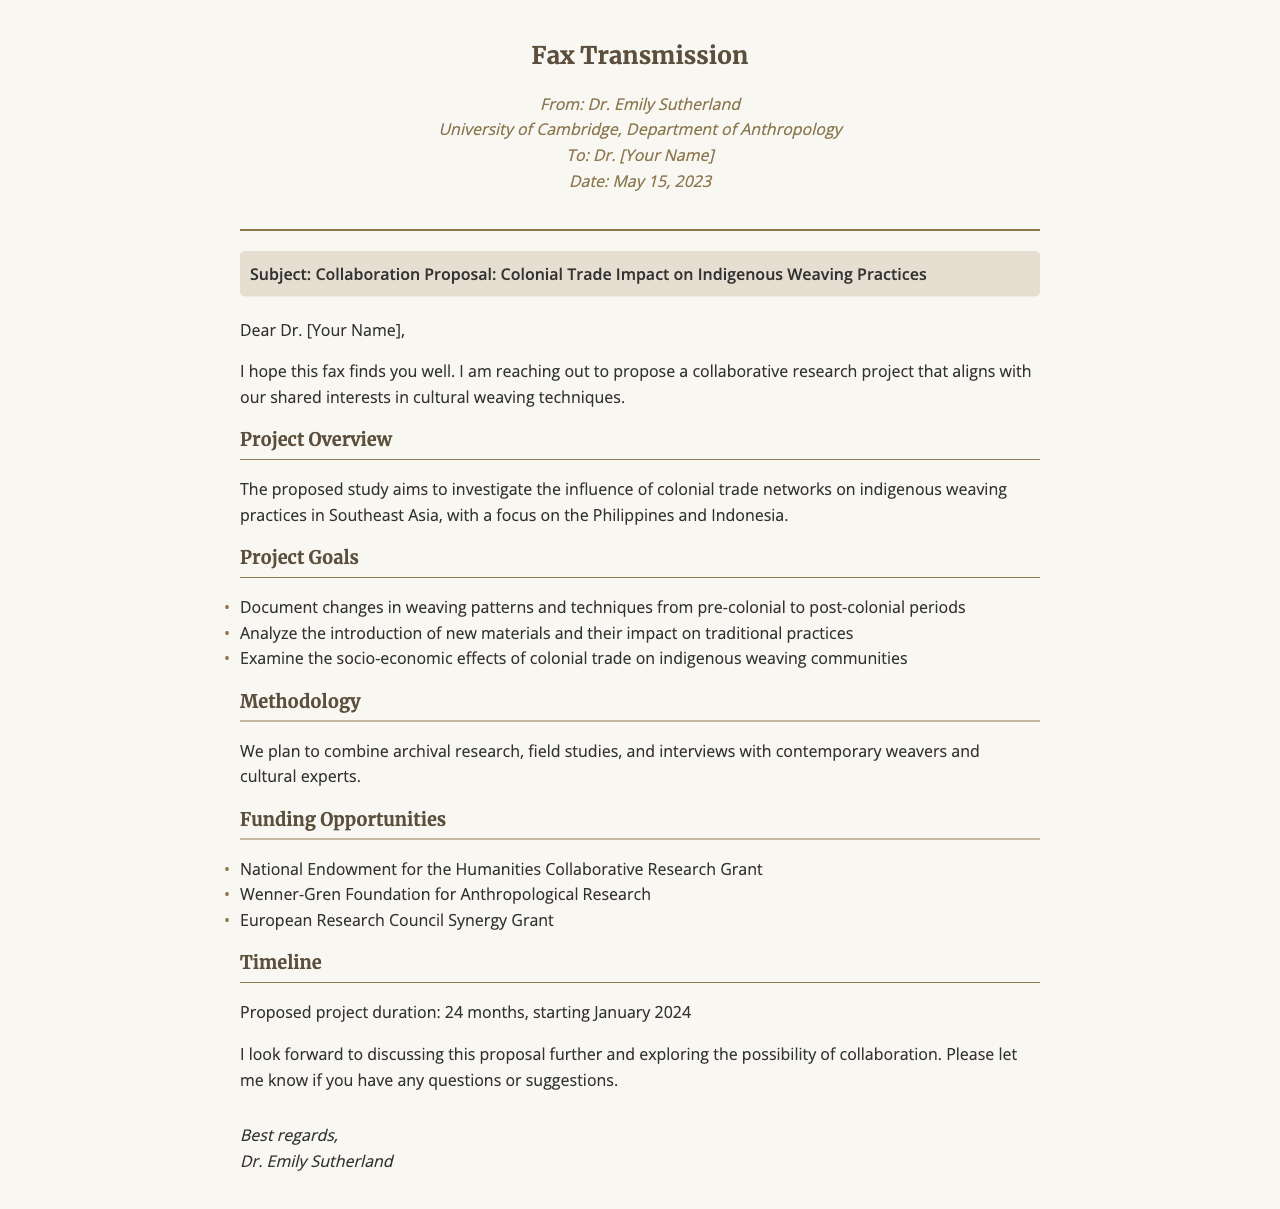What is the sender's name? The sender's name is located at the beginning of the document in the sender info section.
Answer: Dr. Emily Sutherland What is the date of the fax? The date is clearly stated in the sender info section of the document.
Answer: May 15, 2023 What is the subject of the fax? The subject is highlighted in the subject section of the document.
Answer: Collaboration Proposal: Colonial Trade Impact on Indigenous Weaving Practices What are the three project goals listed? The project goals are outlined in a bulleted list under the Project Goals section.
Answer: Document changes in weaving patterns and techniques from pre-colonial to post-colonial periods What is the proposed project duration? The project duration is specified in the Timeline section of the document.
Answer: 24 months What funding opportunities are mentioned? The funding opportunities are listed in a bulleted format under the Funding Opportunities section.
Answer: National Endowment for the Humanities Collaborative Research Grant What methodology will be used in the project? The methodology is briefly mentioned in the Methodology section of the document.
Answer: Archival research, field studies, and interviews Which regions are the focus of the study? The regions are specified in the Project Overview section of the document.
Answer: Southeast Asia, Philippines, and Indonesia What is the primary focus of the proposed study? The primary focus is indicated in the Project Overview section of the document.
Answer: Influence of colonial trade networks on indigenous weaving practices 